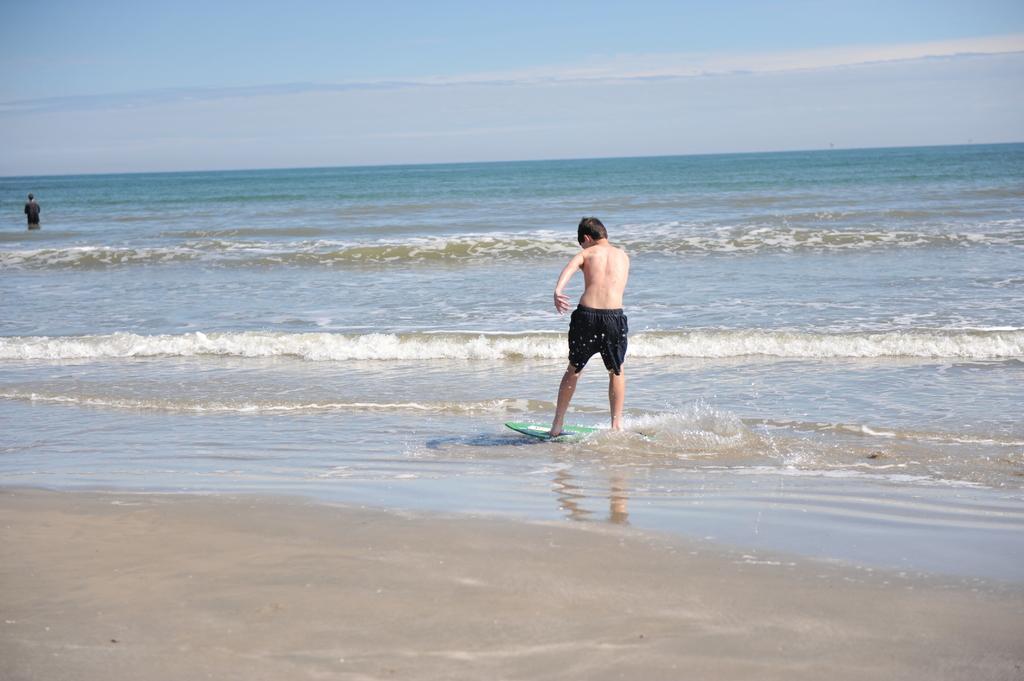Describe this image in one or two sentences. In the image we can see two people standing, they are wearing clothes and shorts. This is a water board, water, sand and a pale blue sky. 